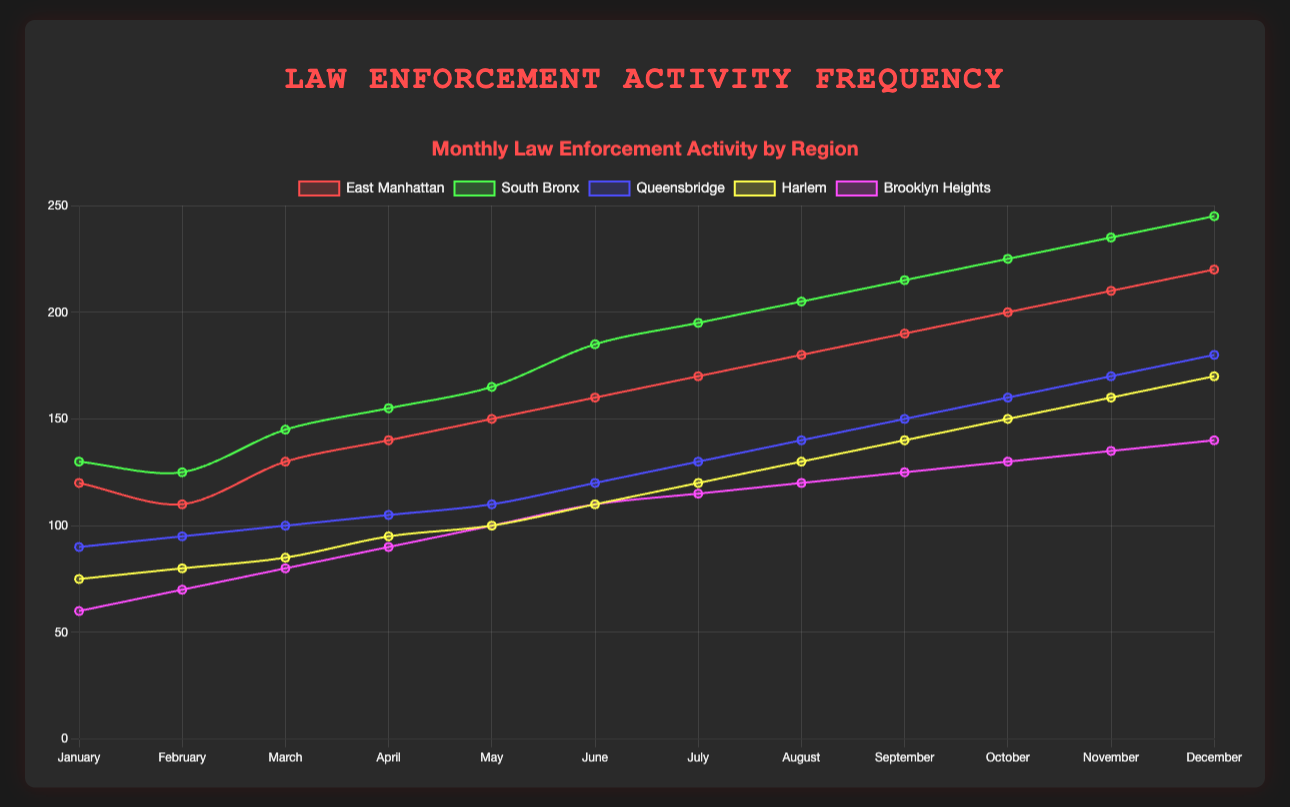Which region has the highest frequency of law enforcement activity by December? To find the region with the highest frequency in December, look at the data points for each region in December. Identify the highest value: East Manhattan (220), South Bronx (245), Queensbridge (180), Harlem (170), Brooklyn Heights (140). The highest is 245, so the region is South Bronx.
Answer: South Bronx How does the frequency of law enforcement activity in Queensbridge in July compare to East Manhattan in July? Look at the July data points for Queensbridge and East Manhattan. Queensbridge has a frequency of 130, and East Manhattan has a frequency of 170. Compare these values: 130 is less than 170.
Answer: Less What is the average frequency of law enforcement activity in Brooklyn Heights from January to June? Sum the frequencies for Brooklyn Heights from January to June (60 + 70 + 80 + 90 + 100 + 110 = 510). There are 6 months, so divide 510 by 6 to get the average.
Answer: 85 Compare the overall trend of law enforcement activity between South Bronx and Harlem throughout the year. Throughout the year, both regions show an increase in law enforcement activity. South Bronx starts higher and ends higher with more significant monthly increases, while Harlem shows a steady but slower increase.
Answer: South Bronx rises faster Which month shows the steepest increase in frequency for East Manhattan, and what is the increase? To find the steepest increase, look for the largest difference in frequency between consecutive months for East Manhattan. The largest increase is from January (120) to February (110) with an increase of 20. Calculate each month's difference to find the maximum.
Answer: March to April, increase of 10 Between March and October, which region sees the most significant growth in frequency? Calculate the frequency difference from March to October for each region: East Manhattan (200 - 130 = 70), South Bronx (225 - 145 = 80), Queensbridge (160 - 100 = 60), Harlem (150 - 85 = 65), Brooklyn Heights (130 - 80 = 50). The region with the most significant growth is South Bronx with 80.
Answer: South Bronx If the same trend continues, what would you estimate the frequency in Brooklyn Heights to be in January of the next year? The trend in Brooklyn Heights shows an approximately 10 frequency point increase every month. December's frequency is 140, so estimate January's frequency by adding 10 to December's frequency (140 + 10 = 150).
Answer: 150 